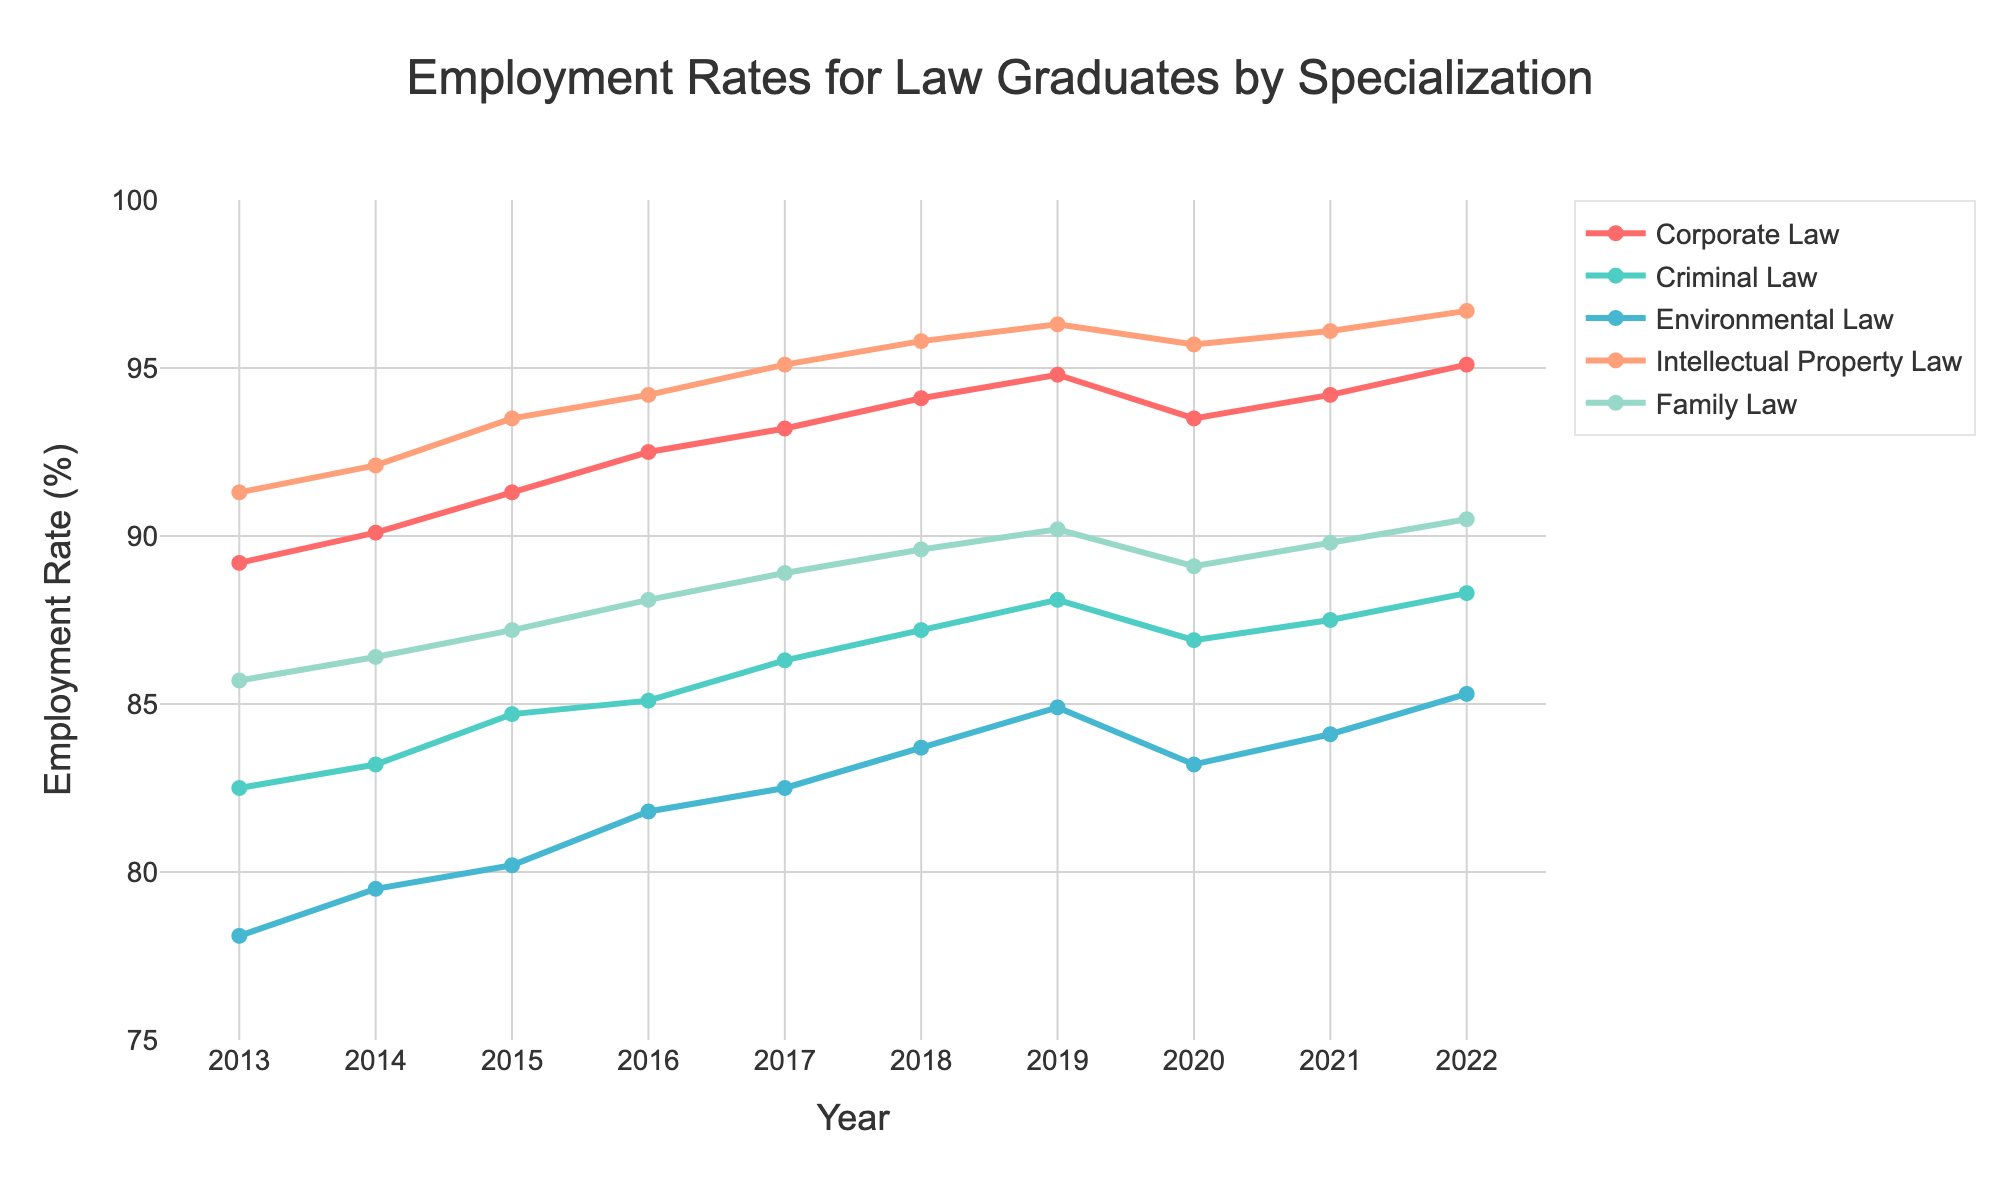What specialization had the highest employment rate in 2022? By looking at the rightmost data points for each line in the figure, we see that the line representing Intellectual Property Law reaches the highest point in 2022.
Answer: Intellectual Property Law Which specialization saw the largest increase in employment rate from 2013 to 2022? By examining the difference between the employment rates in 2022 and 2013 for each specialization, we find that Environmental Law had the biggest increase: from 78.1% in 2013 to 85.3% in 2022, which means an increase of 7.2%.
Answer: Environmental Law Between 2017 and 2019, which specialization showed the most consistent year-on-year increase in employment rate? By comparing the slope of the lines between 2017 and 2019, we observe that the lines for all specializations trend upward, but Intellectual Property Law shows the most consistent and steady increase each year.
Answer: Intellectual Property Law What is the average employment rate for Family Law over the decade? To find the average employment rate for Family Law, sum the employment rates from 2013 to 2022 and then divide by 10: (85.7 + 86.4 + 87.2 + 88.1 + 88.9 + 89.6 + 90.2 + 89.1 + 89.8 + 90.5)/10 = 88.55.
Answer: 88.6% In which year did Criminal Law have the lowest employment rate? By looking at the line corresponding to Criminal Law and identifying the lowest point, we see that the lowest employment rate occurred in 2013 at 82.5%.
Answer: 2013 Which two specializations had nearly equal employment rates in 2020, and how do their rates compare? By observing the 2020 data points, Corporate Law and Intellectual Property Law had nearly identical employment rates in that year, both around 93.5%.
Answer: Corporate Law and Intellectual Property Law Between 2015 and 2016, which specialization experienced the greatest increase in employment rate? By calculating the difference in employment rates between 2015 and 2016, we find that Intellectual Property Law increased from 93.5% to 94.2%, which is an increase of 0.7%, the largest among the specializations.
Answer: Intellectual Property Law How did the employment rate for Environmental Law change from 2019 to 2020? By looking at the data points for Environmental Law in 2019 (84.9%) and 2020 (83.2%), we can calculate the change as 83.2 - 84.9 = -1.7%.
Answer: Decreased by 1.7% Which specialization held the second highest employment rate in 2018? By observing the heights of the data points for 2018, we see that the line for Criminal Law is the second highest, just below Intellectual Property Law.
Answer: Criminal Law 